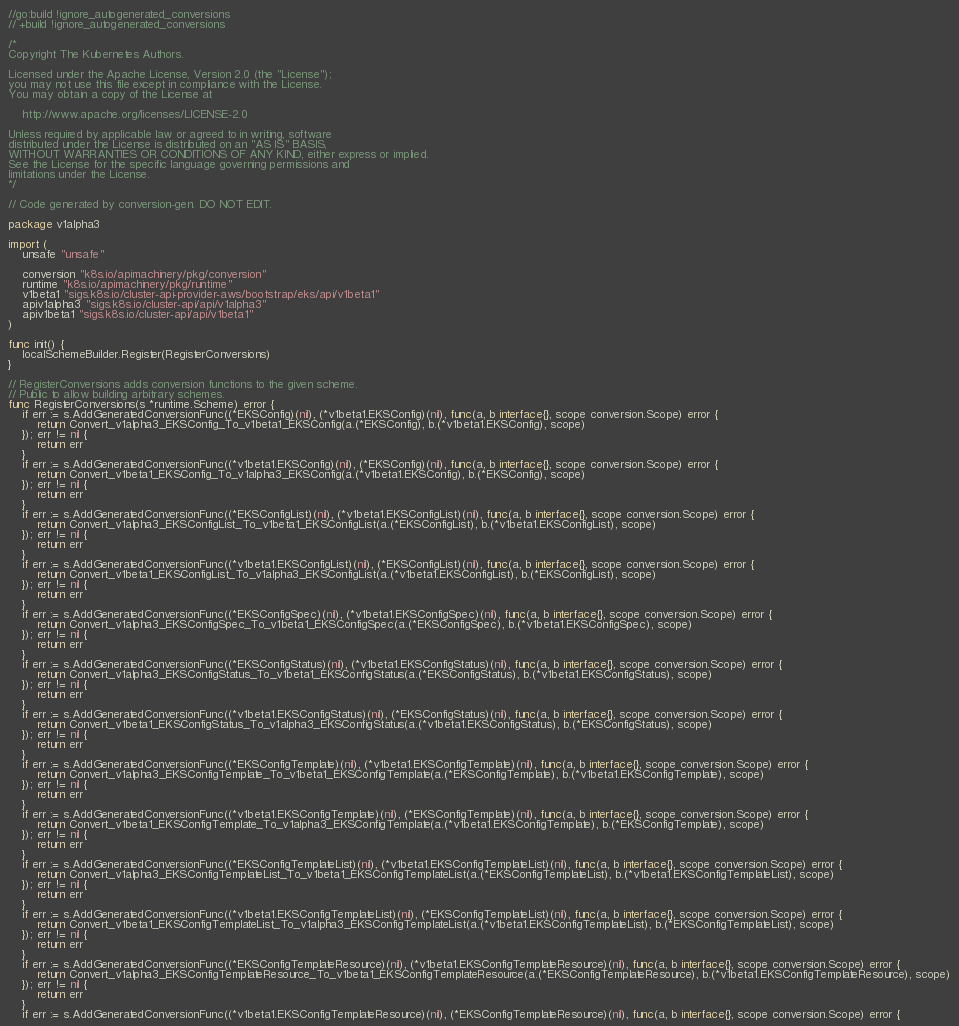Convert code to text. <code><loc_0><loc_0><loc_500><loc_500><_Go_>//go:build !ignore_autogenerated_conversions
// +build !ignore_autogenerated_conversions

/*
Copyright The Kubernetes Authors.

Licensed under the Apache License, Version 2.0 (the "License");
you may not use this file except in compliance with the License.
You may obtain a copy of the License at

    http://www.apache.org/licenses/LICENSE-2.0

Unless required by applicable law or agreed to in writing, software
distributed under the License is distributed on an "AS IS" BASIS,
WITHOUT WARRANTIES OR CONDITIONS OF ANY KIND, either express or implied.
See the License for the specific language governing permissions and
limitations under the License.
*/

// Code generated by conversion-gen. DO NOT EDIT.

package v1alpha3

import (
	unsafe "unsafe"

	conversion "k8s.io/apimachinery/pkg/conversion"
	runtime "k8s.io/apimachinery/pkg/runtime"
	v1beta1 "sigs.k8s.io/cluster-api-provider-aws/bootstrap/eks/api/v1beta1"
	apiv1alpha3 "sigs.k8s.io/cluster-api/api/v1alpha3"
	apiv1beta1 "sigs.k8s.io/cluster-api/api/v1beta1"
)

func init() {
	localSchemeBuilder.Register(RegisterConversions)
}

// RegisterConversions adds conversion functions to the given scheme.
// Public to allow building arbitrary schemes.
func RegisterConversions(s *runtime.Scheme) error {
	if err := s.AddGeneratedConversionFunc((*EKSConfig)(nil), (*v1beta1.EKSConfig)(nil), func(a, b interface{}, scope conversion.Scope) error {
		return Convert_v1alpha3_EKSConfig_To_v1beta1_EKSConfig(a.(*EKSConfig), b.(*v1beta1.EKSConfig), scope)
	}); err != nil {
		return err
	}
	if err := s.AddGeneratedConversionFunc((*v1beta1.EKSConfig)(nil), (*EKSConfig)(nil), func(a, b interface{}, scope conversion.Scope) error {
		return Convert_v1beta1_EKSConfig_To_v1alpha3_EKSConfig(a.(*v1beta1.EKSConfig), b.(*EKSConfig), scope)
	}); err != nil {
		return err
	}
	if err := s.AddGeneratedConversionFunc((*EKSConfigList)(nil), (*v1beta1.EKSConfigList)(nil), func(a, b interface{}, scope conversion.Scope) error {
		return Convert_v1alpha3_EKSConfigList_To_v1beta1_EKSConfigList(a.(*EKSConfigList), b.(*v1beta1.EKSConfigList), scope)
	}); err != nil {
		return err
	}
	if err := s.AddGeneratedConversionFunc((*v1beta1.EKSConfigList)(nil), (*EKSConfigList)(nil), func(a, b interface{}, scope conversion.Scope) error {
		return Convert_v1beta1_EKSConfigList_To_v1alpha3_EKSConfigList(a.(*v1beta1.EKSConfigList), b.(*EKSConfigList), scope)
	}); err != nil {
		return err
	}
	if err := s.AddGeneratedConversionFunc((*EKSConfigSpec)(nil), (*v1beta1.EKSConfigSpec)(nil), func(a, b interface{}, scope conversion.Scope) error {
		return Convert_v1alpha3_EKSConfigSpec_To_v1beta1_EKSConfigSpec(a.(*EKSConfigSpec), b.(*v1beta1.EKSConfigSpec), scope)
	}); err != nil {
		return err
	}
	if err := s.AddGeneratedConversionFunc((*EKSConfigStatus)(nil), (*v1beta1.EKSConfigStatus)(nil), func(a, b interface{}, scope conversion.Scope) error {
		return Convert_v1alpha3_EKSConfigStatus_To_v1beta1_EKSConfigStatus(a.(*EKSConfigStatus), b.(*v1beta1.EKSConfigStatus), scope)
	}); err != nil {
		return err
	}
	if err := s.AddGeneratedConversionFunc((*v1beta1.EKSConfigStatus)(nil), (*EKSConfigStatus)(nil), func(a, b interface{}, scope conversion.Scope) error {
		return Convert_v1beta1_EKSConfigStatus_To_v1alpha3_EKSConfigStatus(a.(*v1beta1.EKSConfigStatus), b.(*EKSConfigStatus), scope)
	}); err != nil {
		return err
	}
	if err := s.AddGeneratedConversionFunc((*EKSConfigTemplate)(nil), (*v1beta1.EKSConfigTemplate)(nil), func(a, b interface{}, scope conversion.Scope) error {
		return Convert_v1alpha3_EKSConfigTemplate_To_v1beta1_EKSConfigTemplate(a.(*EKSConfigTemplate), b.(*v1beta1.EKSConfigTemplate), scope)
	}); err != nil {
		return err
	}
	if err := s.AddGeneratedConversionFunc((*v1beta1.EKSConfigTemplate)(nil), (*EKSConfigTemplate)(nil), func(a, b interface{}, scope conversion.Scope) error {
		return Convert_v1beta1_EKSConfigTemplate_To_v1alpha3_EKSConfigTemplate(a.(*v1beta1.EKSConfigTemplate), b.(*EKSConfigTemplate), scope)
	}); err != nil {
		return err
	}
	if err := s.AddGeneratedConversionFunc((*EKSConfigTemplateList)(nil), (*v1beta1.EKSConfigTemplateList)(nil), func(a, b interface{}, scope conversion.Scope) error {
		return Convert_v1alpha3_EKSConfigTemplateList_To_v1beta1_EKSConfigTemplateList(a.(*EKSConfigTemplateList), b.(*v1beta1.EKSConfigTemplateList), scope)
	}); err != nil {
		return err
	}
	if err := s.AddGeneratedConversionFunc((*v1beta1.EKSConfigTemplateList)(nil), (*EKSConfigTemplateList)(nil), func(a, b interface{}, scope conversion.Scope) error {
		return Convert_v1beta1_EKSConfigTemplateList_To_v1alpha3_EKSConfigTemplateList(a.(*v1beta1.EKSConfigTemplateList), b.(*EKSConfigTemplateList), scope)
	}); err != nil {
		return err
	}
	if err := s.AddGeneratedConversionFunc((*EKSConfigTemplateResource)(nil), (*v1beta1.EKSConfigTemplateResource)(nil), func(a, b interface{}, scope conversion.Scope) error {
		return Convert_v1alpha3_EKSConfigTemplateResource_To_v1beta1_EKSConfigTemplateResource(a.(*EKSConfigTemplateResource), b.(*v1beta1.EKSConfigTemplateResource), scope)
	}); err != nil {
		return err
	}
	if err := s.AddGeneratedConversionFunc((*v1beta1.EKSConfigTemplateResource)(nil), (*EKSConfigTemplateResource)(nil), func(a, b interface{}, scope conversion.Scope) error {</code> 